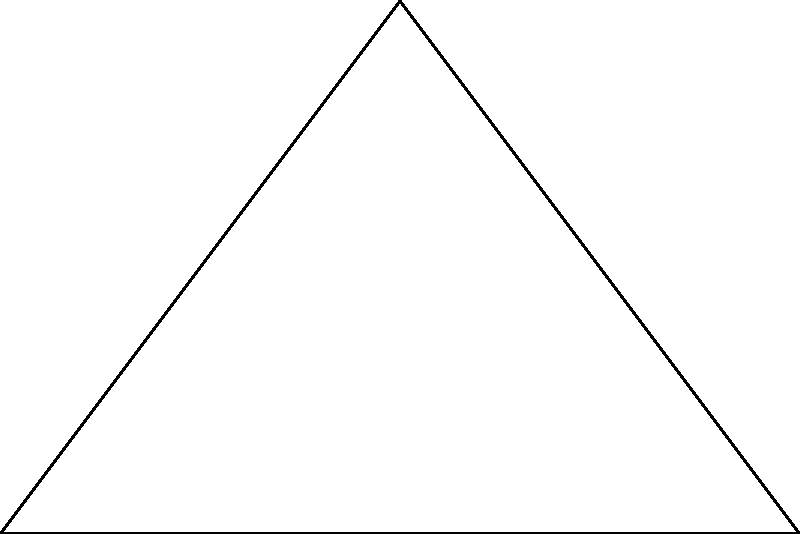In a public square, we need to place surveillance cameras at points A and B to monitor the entire area. The distance between A and B is 6 units, and there's a critical observation point C forming a right-angled triangle with A and B. If the angle at A is 60°, what is the optimal height (AC) at which the camera should be placed at point A to ensure maximum coverage? Let's approach this step-by-step:

1) We have a right-angled triangle ABC, where:
   - AB = 6 units
   - Angle BAC = 60°
   - Angle ABC = 90° (right angle)

2) In a 30-60-90 triangle, the sides are in the ratio of 1 : $\sqrt{3}$ : 2

3) Here, AB is the longest side (hypotenuse), so:
   AB : AC : BC = 2 : $\sqrt{3}$ : 1

4) We know AB = 6, so we can set up the proportion:
   $\frac{6}{2} = \frac{AC}{\sqrt{3}}$

5) Cross multiply:
   $6\sqrt{3} = 2AC$

6) Solve for AC:
   $AC = \frac{6\sqrt{3}}{2} = 3\sqrt{3}$

Therefore, the optimal height at which the camera should be placed at point A is $3\sqrt{3}$ units.
Answer: $3\sqrt{3}$ units 